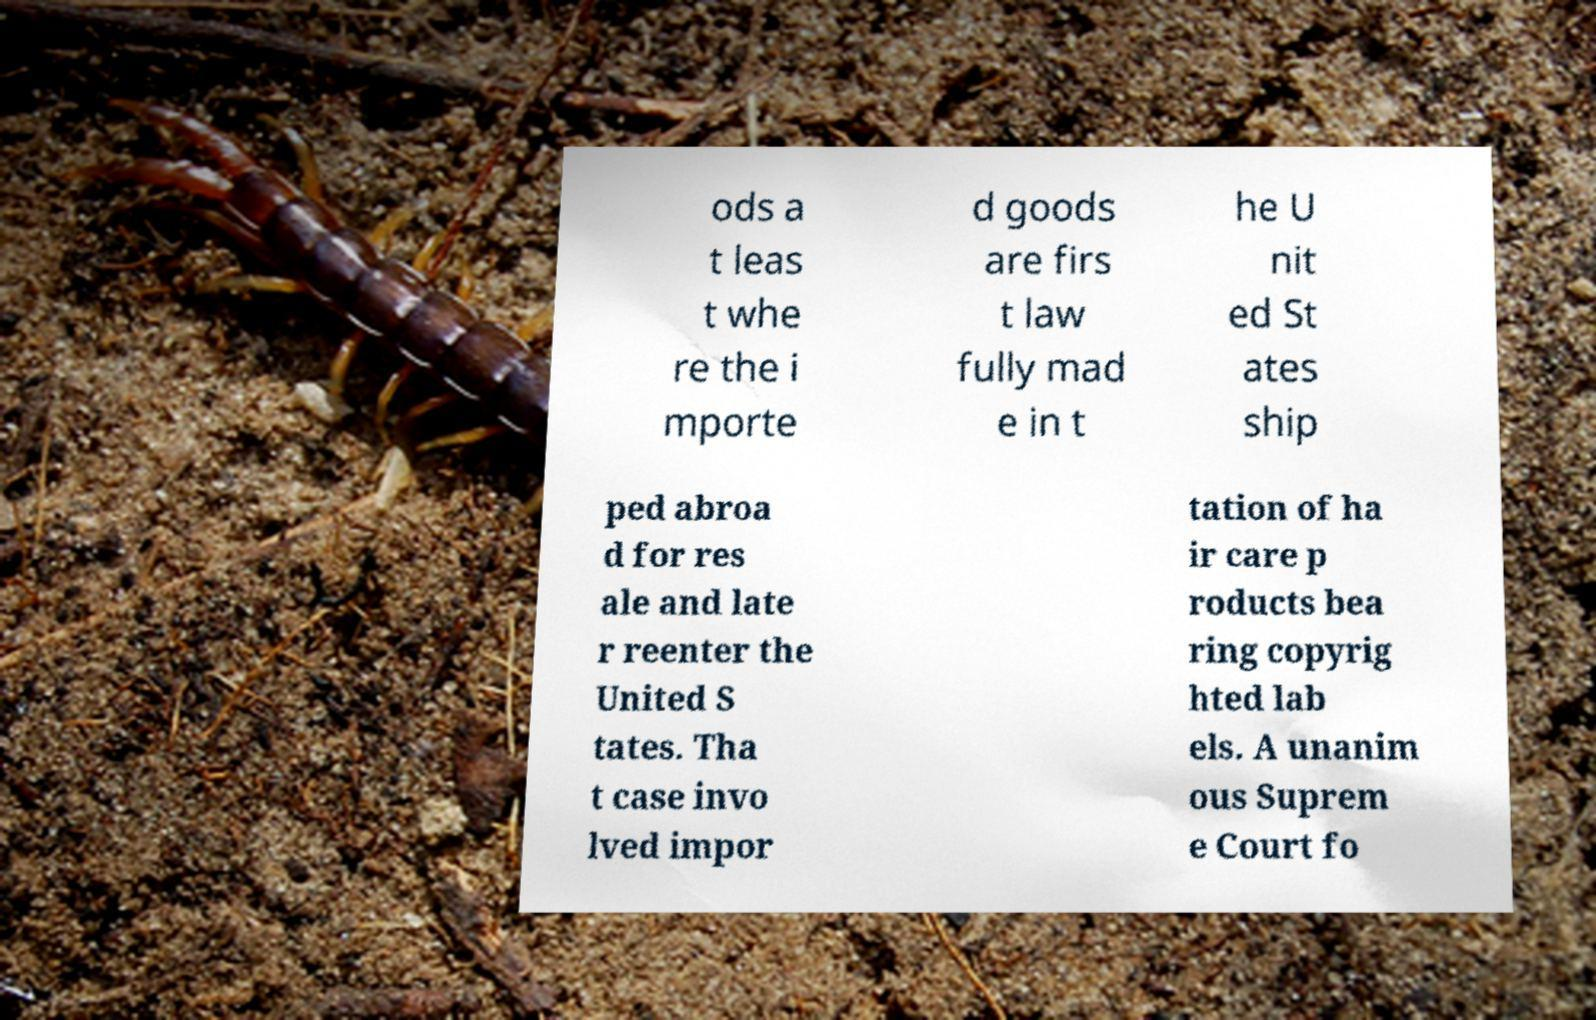Can you accurately transcribe the text from the provided image for me? ods a t leas t whe re the i mporte d goods are firs t law fully mad e in t he U nit ed St ates ship ped abroa d for res ale and late r reenter the United S tates. Tha t case invo lved impor tation of ha ir care p roducts bea ring copyrig hted lab els. A unanim ous Suprem e Court fo 